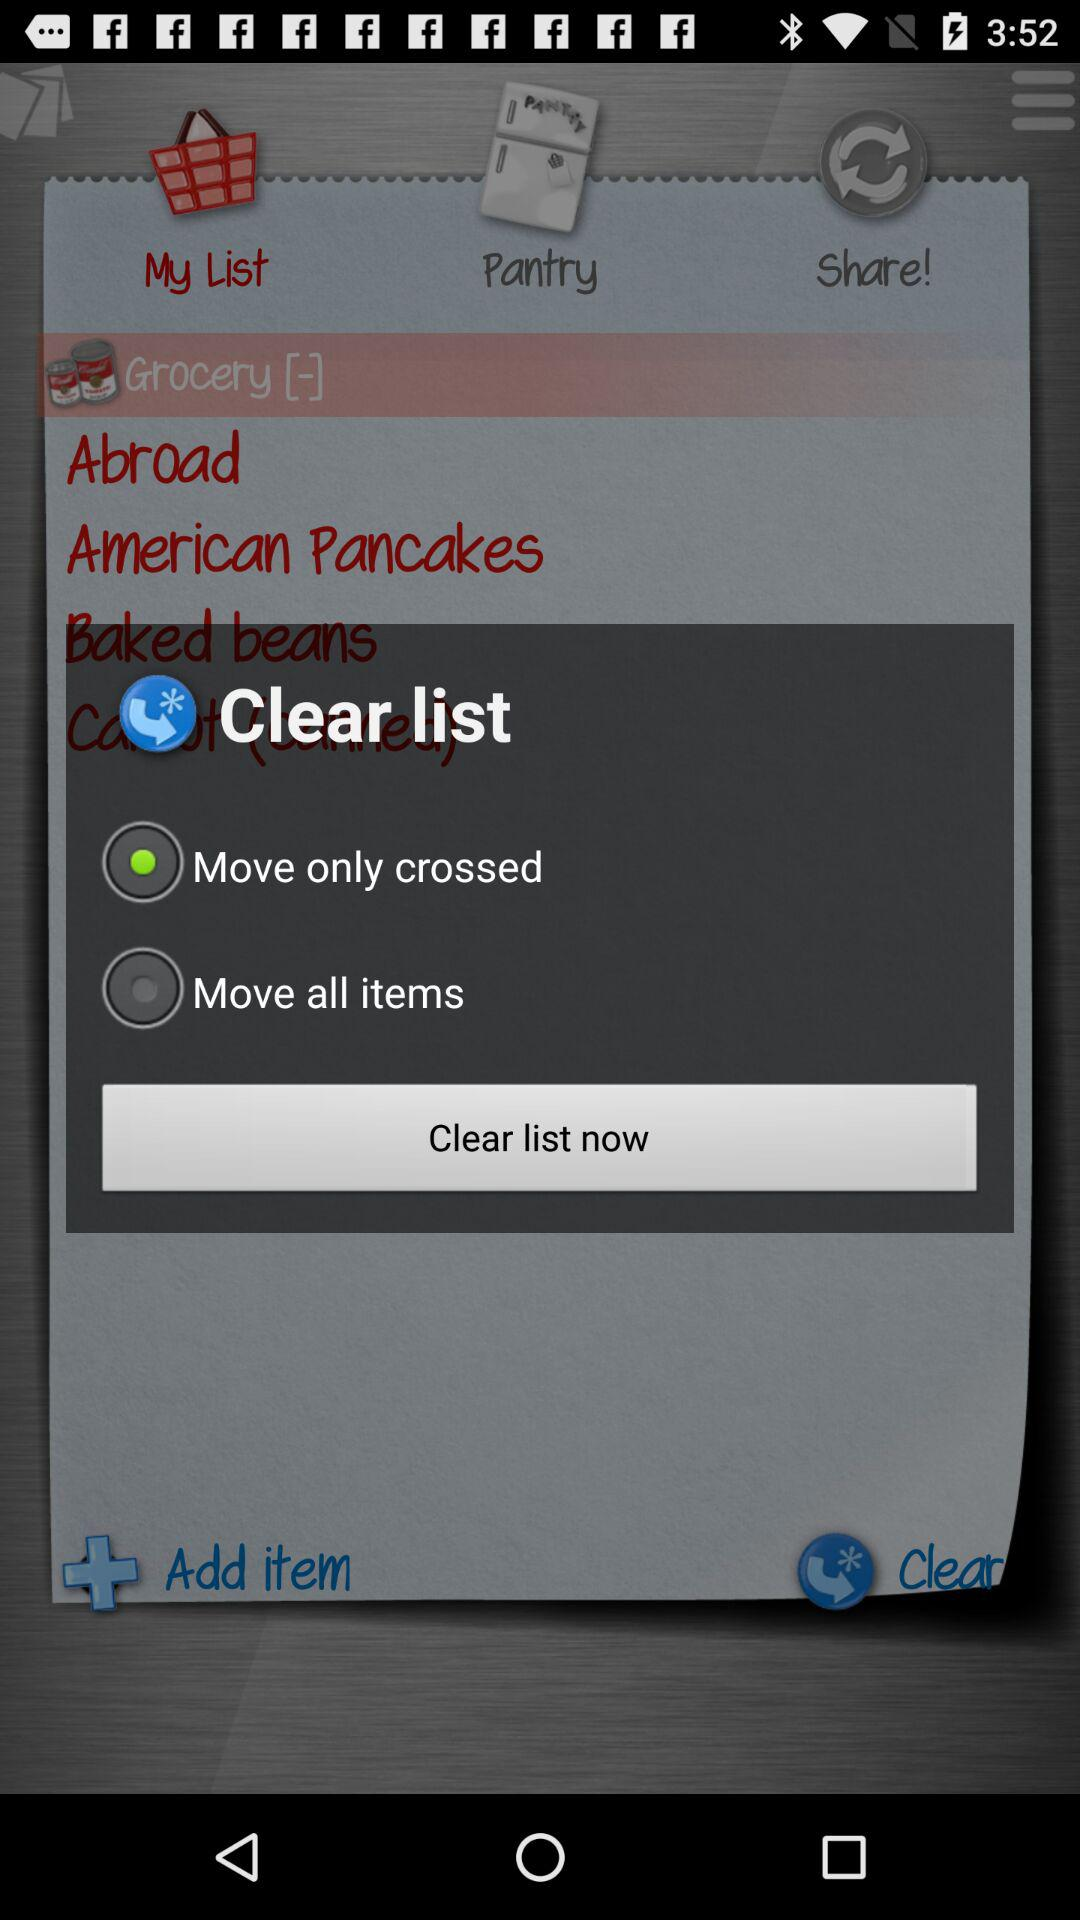How many items are in the pantry?
When the provided information is insufficient, respond with <no answer>. <no answer> 